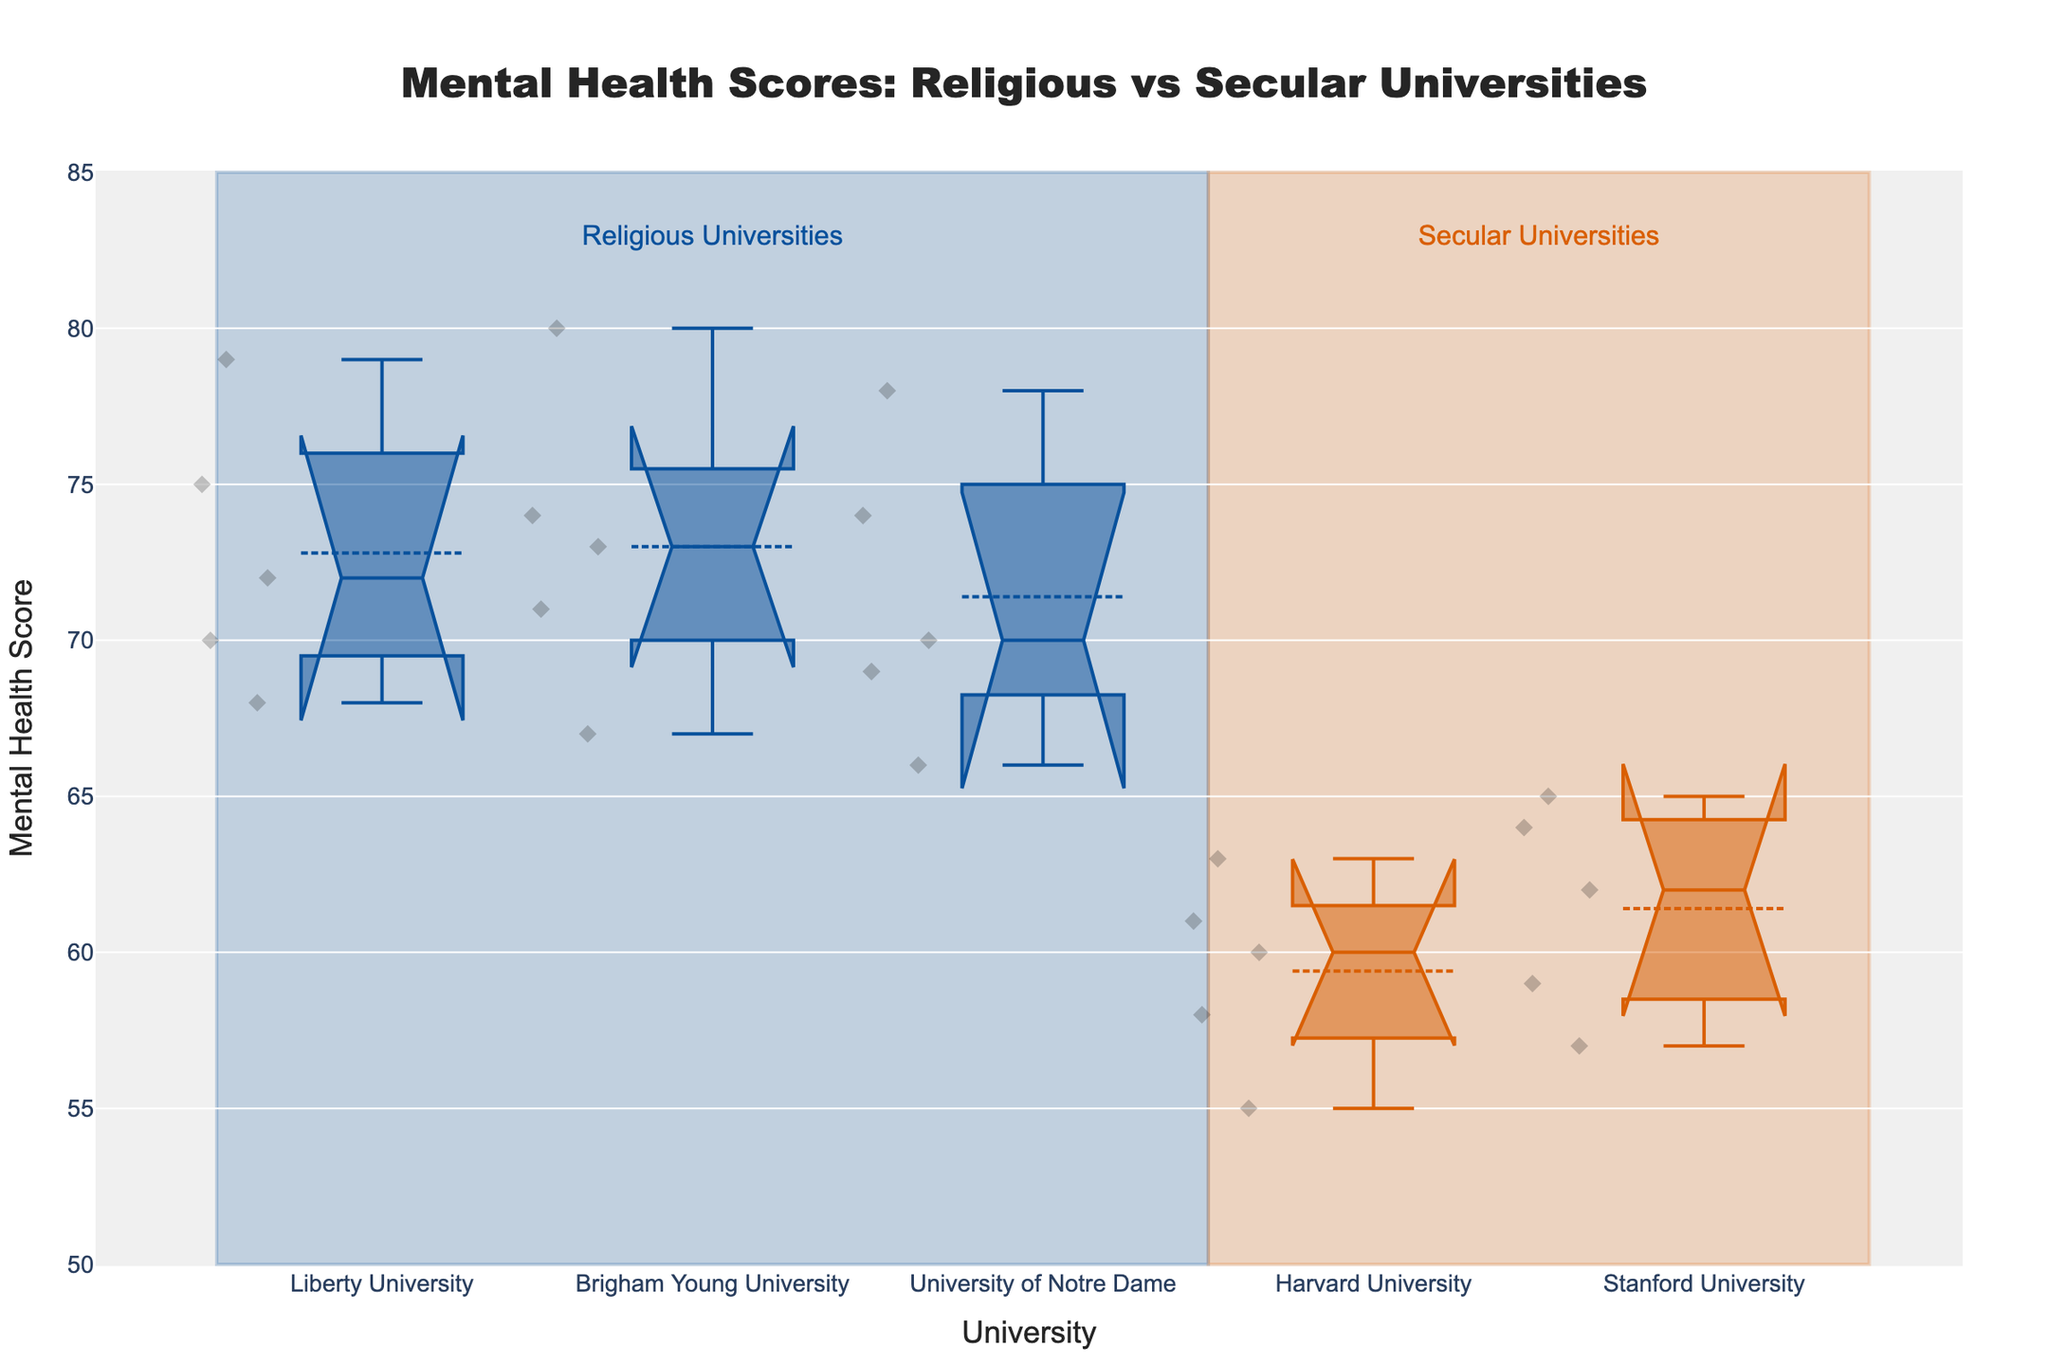What's the title of the plot? The title is displayed at the top of the plot.
Answer: Mental Health Scores: Religious vs Secular Universities How many religious universities are shown in the plot? The plot highlights the universities and their type, with the religious universities colored in blue and annotated as such.
Answer: 3 What is the median mental health score for Liberty University? The median score of Liberty University is represented by the line inside the box for this university.
Answer: 72 Which university has the lowest recorded mental health score? The plot displays individual data points, with the one closest to the bottom of the y-axis indicating the lowest score. This is found at Harvard University with a score of 55.
Answer: Harvard University Are the medians of mental health scores of secular universities generally higher or lower than those of religious universities? By comparing the lines inside the boxes for each group, we see that the medians for secular universities are generally lower.
Answer: Lower What is the range of mental health scores for Stanford University? The range is determined by the maximum and minimum points within the whiskers of Stanford University's box plot.
Answer: 57-65 Among the universities shown, which has the widest spread of mental health scores? We compare the lengths of the boxes along with their whiskers. The widest spread is for Liberty University.
Answer: Liberty University What does the notched section in each box plot represent? The notches represent the confidence intervals around the median. If the notches of two boxes do not overlap, it suggests that the medians are significantly different.
Answer: Confidence intervals Is there an overlap in the interquartile ranges (IQR) of religious and secular universities? By examining the location and span of each box (the box represents the IQR), we can observe that there is an overlap in the collective interquartile ranges between the two groups.
Answer: Yes 